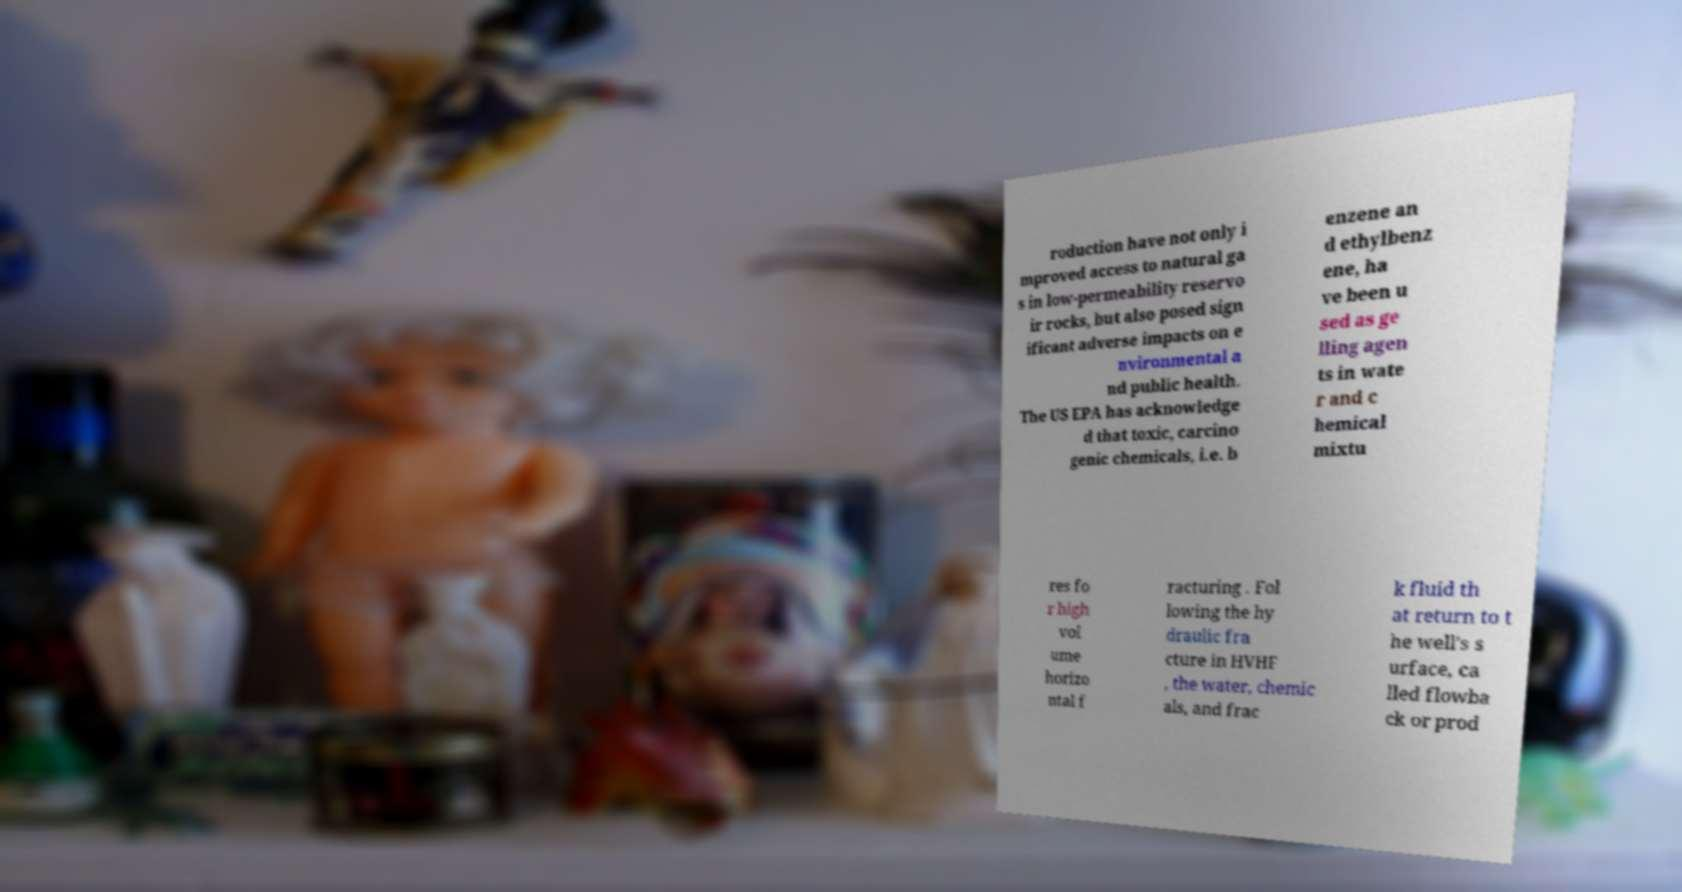Please identify and transcribe the text found in this image. roduction have not only i mproved access to natural ga s in low-permeability reservo ir rocks, but also posed sign ificant adverse impacts on e nvironmental a nd public health. The US EPA has acknowledge d that toxic, carcino genic chemicals, i.e. b enzene an d ethylbenz ene, ha ve been u sed as ge lling agen ts in wate r and c hemical mixtu res fo r high vol ume horizo ntal f racturing . Fol lowing the hy draulic fra cture in HVHF , the water, chemic als, and frac k fluid th at return to t he well's s urface, ca lled flowba ck or prod 